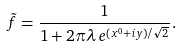<formula> <loc_0><loc_0><loc_500><loc_500>\tilde { f } = \frac { 1 } { 1 + 2 \pi \lambda \, e ^ { ( x ^ { 0 } + i y ) / \sqrt { 2 } } } .</formula> 